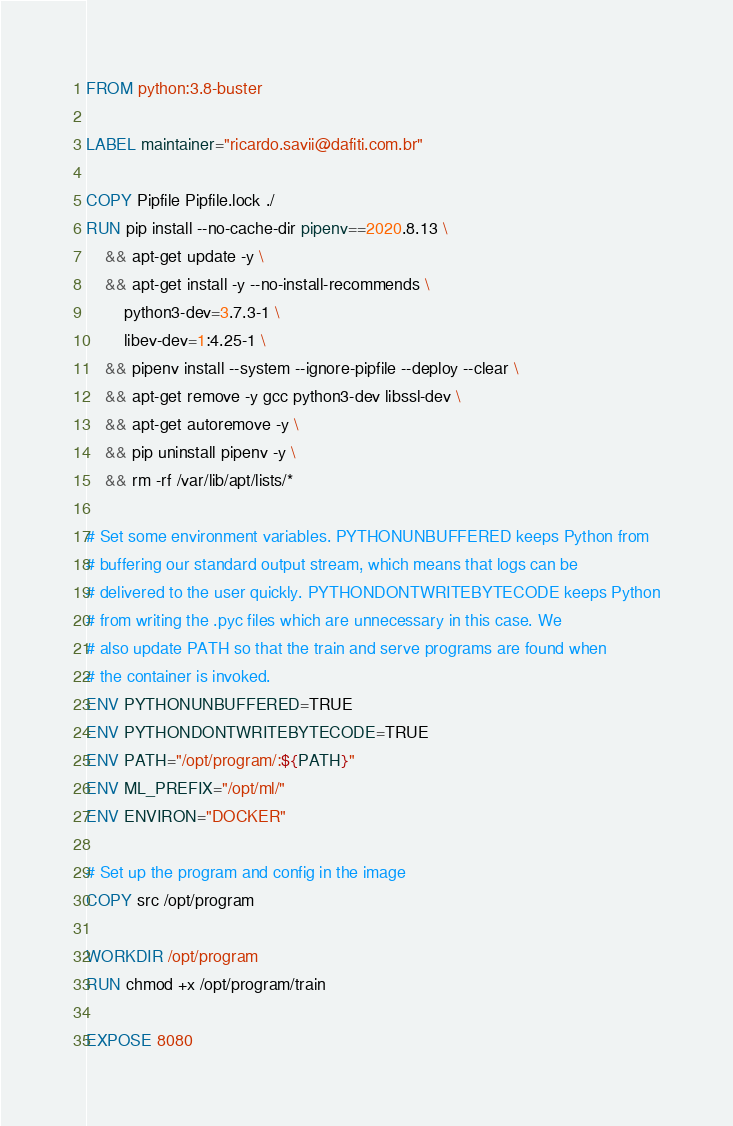Convert code to text. <code><loc_0><loc_0><loc_500><loc_500><_Dockerfile_>FROM python:3.8-buster

LABEL maintainer="ricardo.savii@dafiti.com.br"

COPY Pipfile Pipfile.lock ./
RUN pip install --no-cache-dir pipenv==2020.8.13 \
    && apt-get update -y \
    && apt-get install -y --no-install-recommends \
        python3-dev=3.7.3-1 \
        libev-dev=1:4.25-1 \
    && pipenv install --system --ignore-pipfile --deploy --clear \
    && apt-get remove -y gcc python3-dev libssl-dev \
    && apt-get autoremove -y \
    && pip uninstall pipenv -y \
    && rm -rf /var/lib/apt/lists/*

# Set some environment variables. PYTHONUNBUFFERED keeps Python from
# buffering our standard output stream, which means that logs can be
# delivered to the user quickly. PYTHONDONTWRITEBYTECODE keeps Python
# from writing the .pyc files which are unnecessary in this case. We
# also update PATH so that the train and serve programs are found when
# the container is invoked.
ENV PYTHONUNBUFFERED=TRUE
ENV PYTHONDONTWRITEBYTECODE=TRUE
ENV PATH="/opt/program/:${PATH}"
ENV ML_PREFIX="/opt/ml/"
ENV ENVIRON="DOCKER"

# Set up the program and config in the image
COPY src /opt/program

WORKDIR /opt/program
RUN chmod +x /opt/program/train

EXPOSE 8080
</code> 